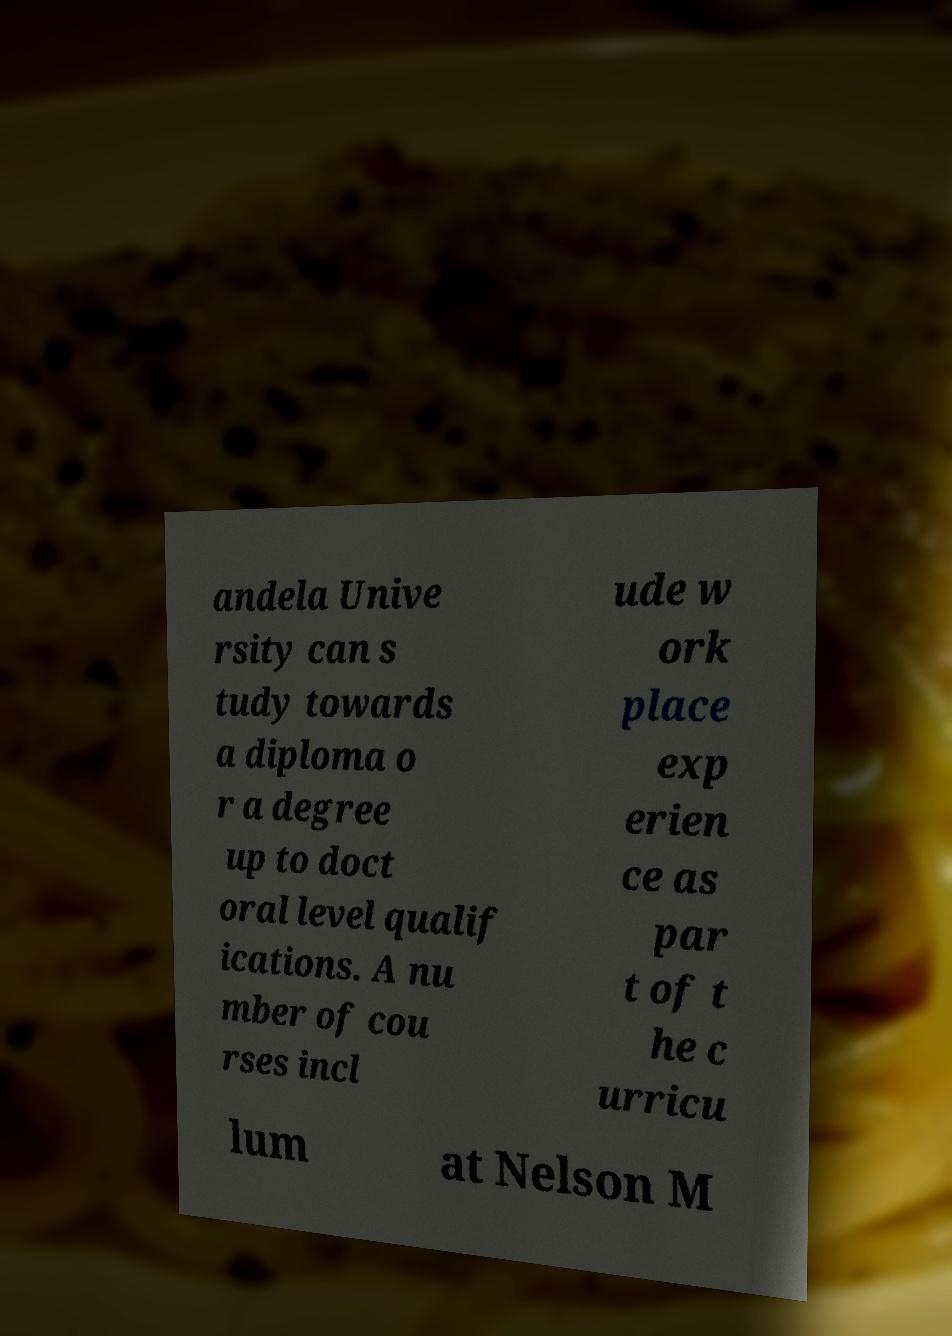Please identify and transcribe the text found in this image. andela Unive rsity can s tudy towards a diploma o r a degree up to doct oral level qualif ications. A nu mber of cou rses incl ude w ork place exp erien ce as par t of t he c urricu lum at Nelson M 